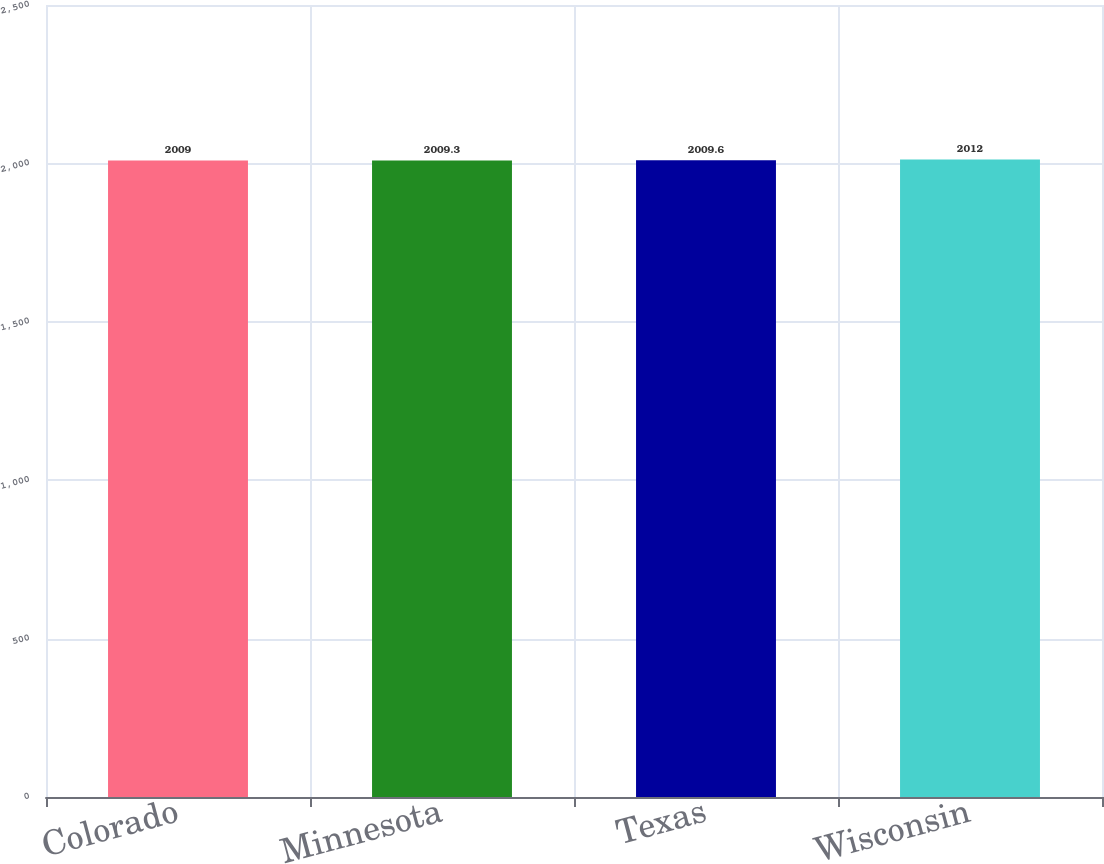Convert chart. <chart><loc_0><loc_0><loc_500><loc_500><bar_chart><fcel>Colorado<fcel>Minnesota<fcel>Texas<fcel>Wisconsin<nl><fcel>2009<fcel>2009.3<fcel>2009.6<fcel>2012<nl></chart> 